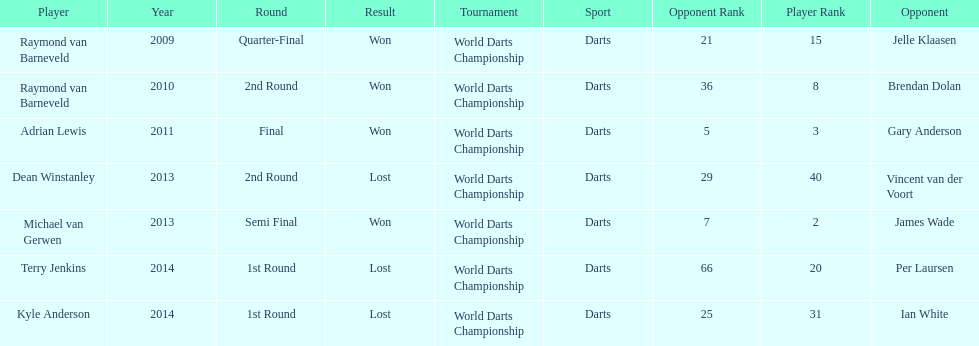Name a year with more than one game listed. 2013. Would you mind parsing the complete table? {'header': ['Player', 'Year', 'Round', 'Result', 'Tournament', 'Sport', 'Opponent Rank', 'Player Rank', 'Opponent'], 'rows': [['Raymond van Barneveld', '2009', 'Quarter-Final', 'Won', 'World Darts Championship', 'Darts', '21', '15', 'Jelle Klaasen'], ['Raymond van Barneveld', '2010', '2nd Round', 'Won', 'World Darts Championship', 'Darts', '36', '8', 'Brendan Dolan'], ['Adrian Lewis', '2011', 'Final', 'Won', 'World Darts Championship', 'Darts', '5', '3', 'Gary Anderson'], ['Dean Winstanley', '2013', '2nd Round', 'Lost', 'World Darts Championship', 'Darts', '29', '40', 'Vincent van der Voort'], ['Michael van Gerwen', '2013', 'Semi Final', 'Won', 'World Darts Championship', 'Darts', '7', '2', 'James Wade'], ['Terry Jenkins', '2014', '1st Round', 'Lost', 'World Darts Championship', 'Darts', '66', '20', 'Per Laursen'], ['Kyle Anderson', '2014', '1st Round', 'Lost', 'World Darts Championship', 'Darts', '25', '31', 'Ian White']]} 